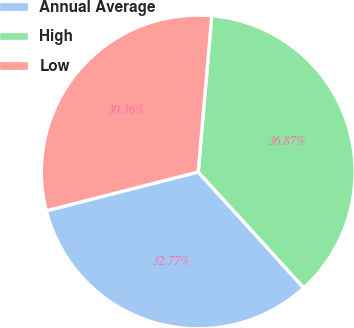<chart> <loc_0><loc_0><loc_500><loc_500><pie_chart><fcel>Annual Average<fcel>High<fcel>Low<nl><fcel>32.77%<fcel>36.87%<fcel>30.36%<nl></chart> 